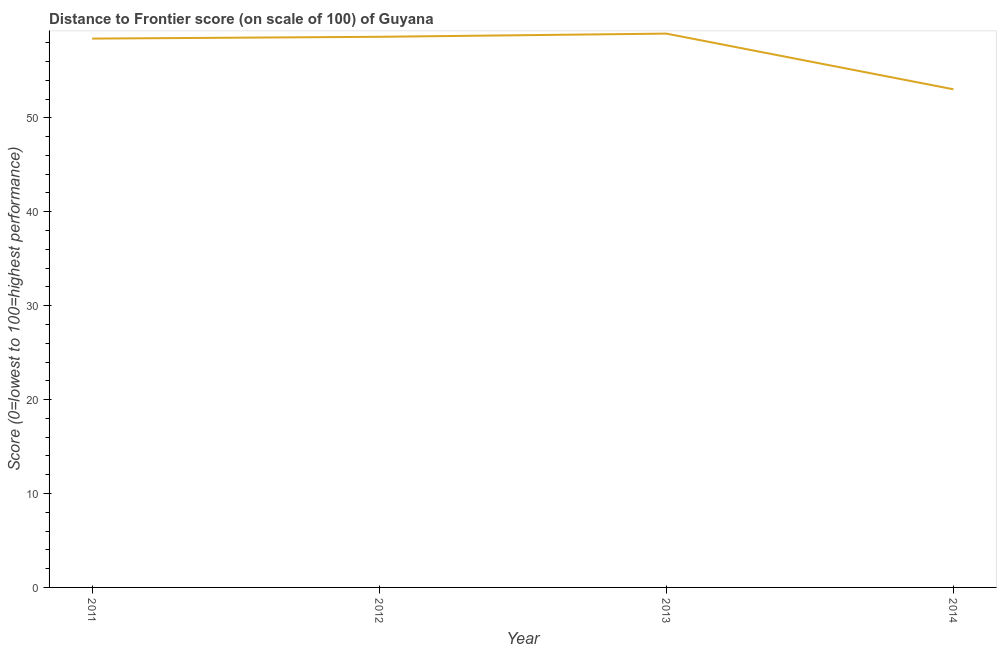What is the distance to frontier score in 2013?
Keep it short and to the point. 58.97. Across all years, what is the maximum distance to frontier score?
Make the answer very short. 58.97. Across all years, what is the minimum distance to frontier score?
Your answer should be compact. 53.04. In which year was the distance to frontier score maximum?
Your answer should be very brief. 2013. What is the sum of the distance to frontier score?
Provide a succinct answer. 229.08. What is the difference between the distance to frontier score in 2012 and 2013?
Offer a terse response. -0.34. What is the average distance to frontier score per year?
Your answer should be compact. 57.27. What is the median distance to frontier score?
Make the answer very short. 58.53. What is the ratio of the distance to frontier score in 2012 to that in 2013?
Your answer should be very brief. 0.99. What is the difference between the highest and the second highest distance to frontier score?
Provide a short and direct response. 0.34. What is the difference between the highest and the lowest distance to frontier score?
Offer a very short reply. 5.93. In how many years, is the distance to frontier score greater than the average distance to frontier score taken over all years?
Provide a short and direct response. 3. Does the distance to frontier score monotonically increase over the years?
Keep it short and to the point. No. How many years are there in the graph?
Make the answer very short. 4. What is the difference between two consecutive major ticks on the Y-axis?
Your answer should be compact. 10. Are the values on the major ticks of Y-axis written in scientific E-notation?
Give a very brief answer. No. Does the graph contain grids?
Your answer should be compact. No. What is the title of the graph?
Provide a short and direct response. Distance to Frontier score (on scale of 100) of Guyana. What is the label or title of the Y-axis?
Your answer should be compact. Score (0=lowest to 100=highest performance). What is the Score (0=lowest to 100=highest performance) in 2011?
Offer a very short reply. 58.44. What is the Score (0=lowest to 100=highest performance) of 2012?
Your response must be concise. 58.63. What is the Score (0=lowest to 100=highest performance) of 2013?
Your answer should be compact. 58.97. What is the Score (0=lowest to 100=highest performance) of 2014?
Provide a succinct answer. 53.04. What is the difference between the Score (0=lowest to 100=highest performance) in 2011 and 2012?
Offer a terse response. -0.19. What is the difference between the Score (0=lowest to 100=highest performance) in 2011 and 2013?
Make the answer very short. -0.53. What is the difference between the Score (0=lowest to 100=highest performance) in 2011 and 2014?
Your response must be concise. 5.4. What is the difference between the Score (0=lowest to 100=highest performance) in 2012 and 2013?
Provide a short and direct response. -0.34. What is the difference between the Score (0=lowest to 100=highest performance) in 2012 and 2014?
Provide a succinct answer. 5.59. What is the difference between the Score (0=lowest to 100=highest performance) in 2013 and 2014?
Provide a short and direct response. 5.93. What is the ratio of the Score (0=lowest to 100=highest performance) in 2011 to that in 2013?
Your answer should be compact. 0.99. What is the ratio of the Score (0=lowest to 100=highest performance) in 2011 to that in 2014?
Make the answer very short. 1.1. What is the ratio of the Score (0=lowest to 100=highest performance) in 2012 to that in 2013?
Your answer should be compact. 0.99. What is the ratio of the Score (0=lowest to 100=highest performance) in 2012 to that in 2014?
Provide a short and direct response. 1.1. What is the ratio of the Score (0=lowest to 100=highest performance) in 2013 to that in 2014?
Your answer should be compact. 1.11. 